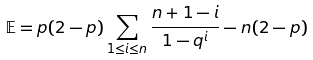Convert formula to latex. <formula><loc_0><loc_0><loc_500><loc_500>\mathbb { E } = p ( 2 - p ) \sum _ { 1 \leq i \leq n } \frac { n + 1 - i } { 1 - q ^ { i } } - n ( 2 - p )</formula> 